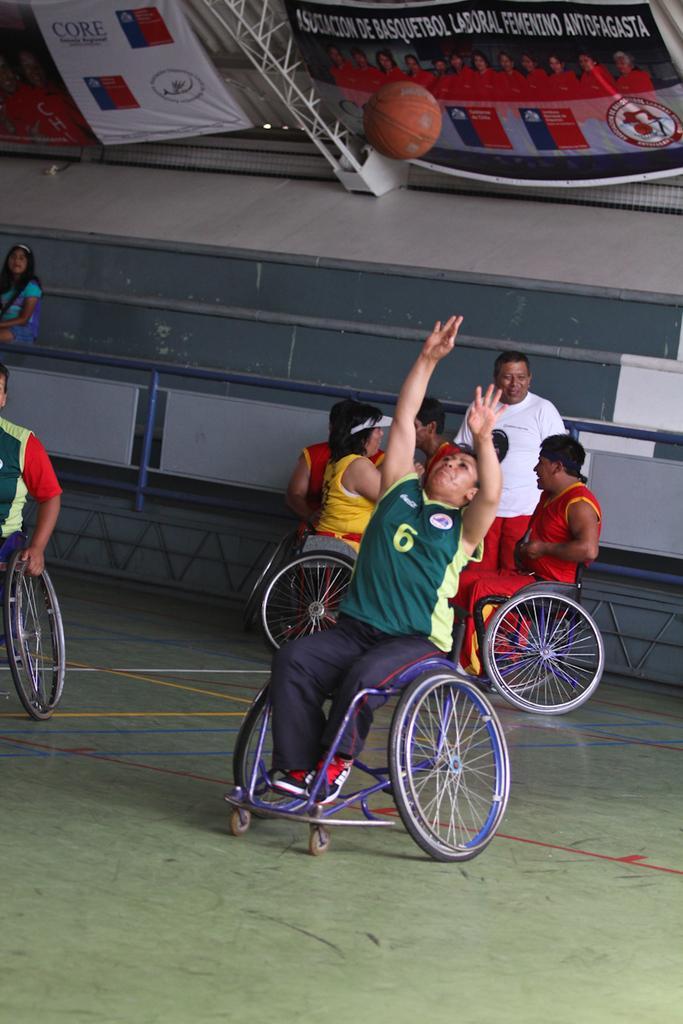Can you describe this image briefly? In the center of the image there are many persons sitting on the wheel chairs. At the top of the image we can see ball and posters. In the background we can see stairs, persons and wall. 